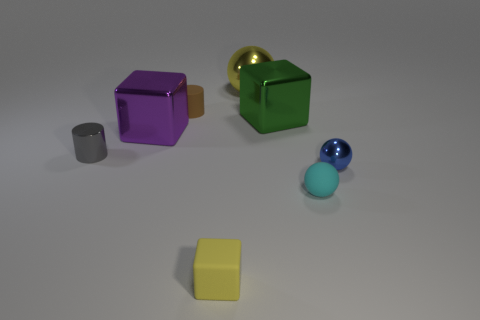Add 1 small gray metallic things. How many objects exist? 9 Subtract all balls. How many objects are left? 5 Add 2 small cyan matte things. How many small cyan matte things exist? 3 Subtract 0 yellow cylinders. How many objects are left? 8 Subtract all yellow balls. Subtract all large yellow metal spheres. How many objects are left? 6 Add 3 big yellow balls. How many big yellow balls are left? 4 